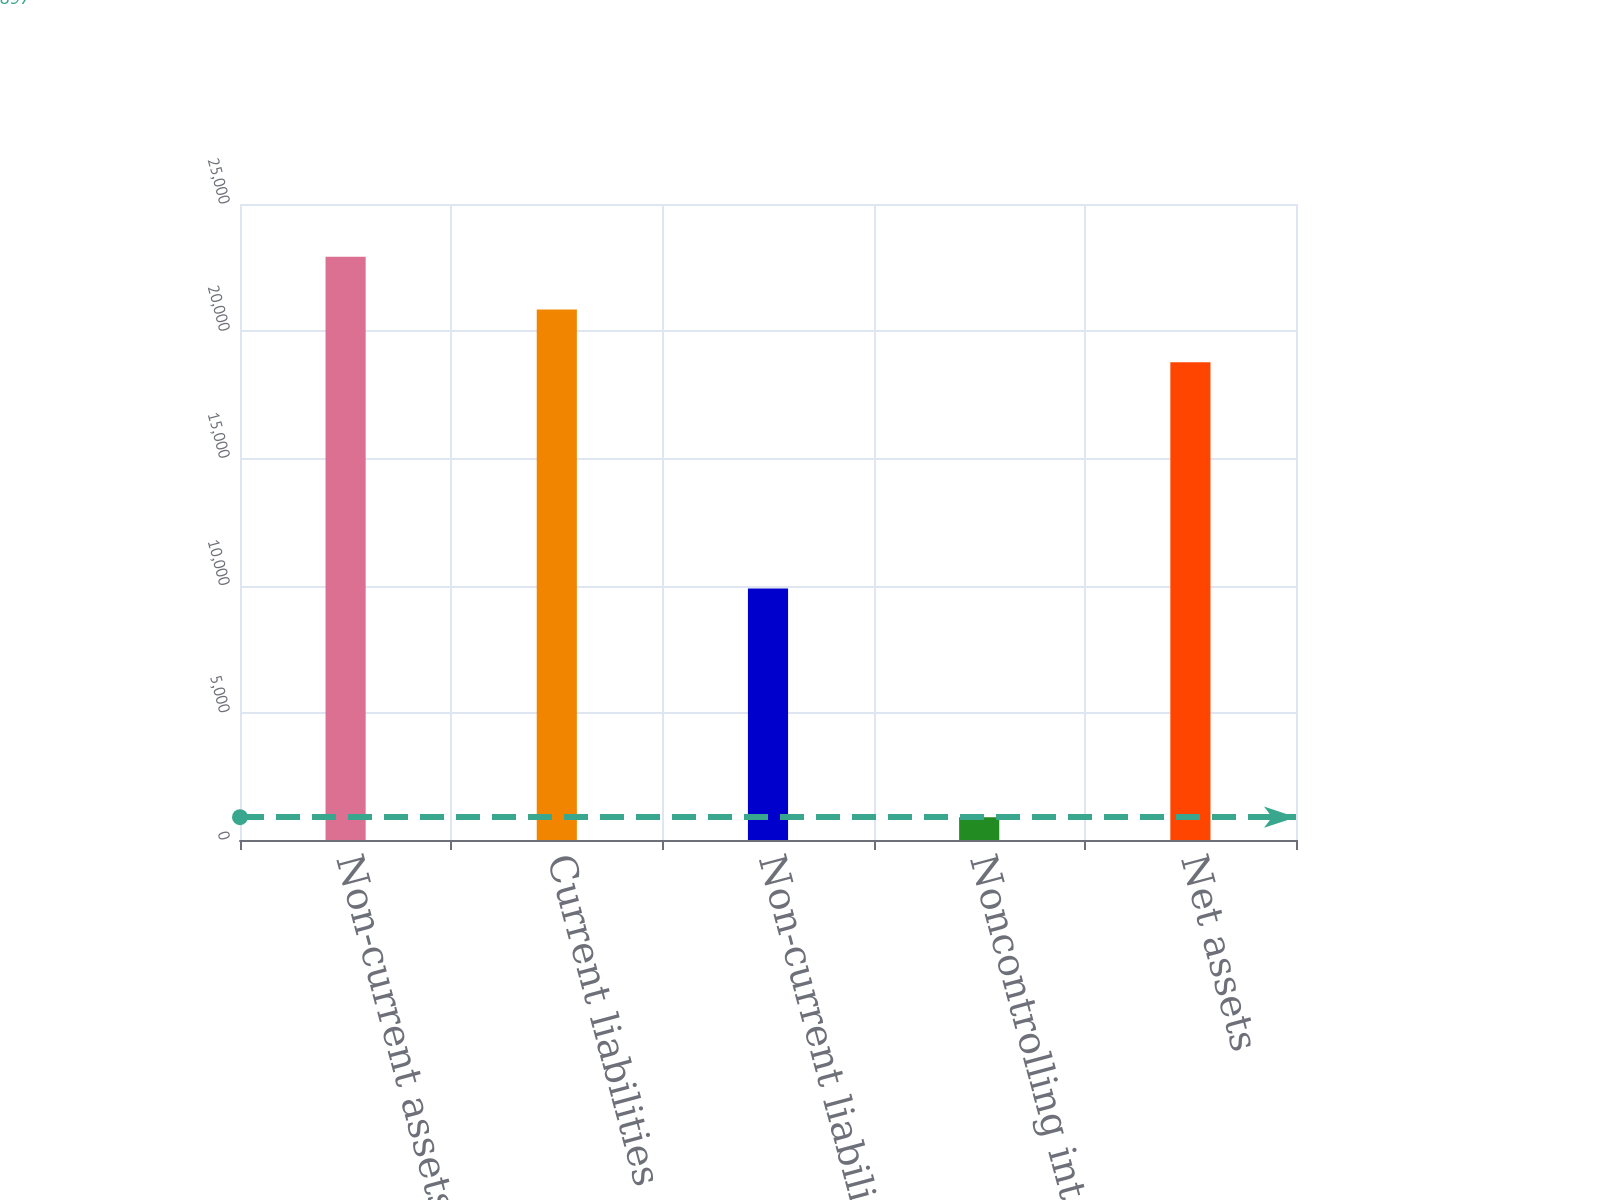Convert chart to OTSL. <chart><loc_0><loc_0><loc_500><loc_500><bar_chart><fcel>Non-current assets<fcel>Current liabilities<fcel>Non-current liabilities<fcel>Noncontrolling interests<fcel>Net assets<nl><fcel>22927.4<fcel>20854.7<fcel>9882<fcel>897<fcel>18782<nl></chart> 